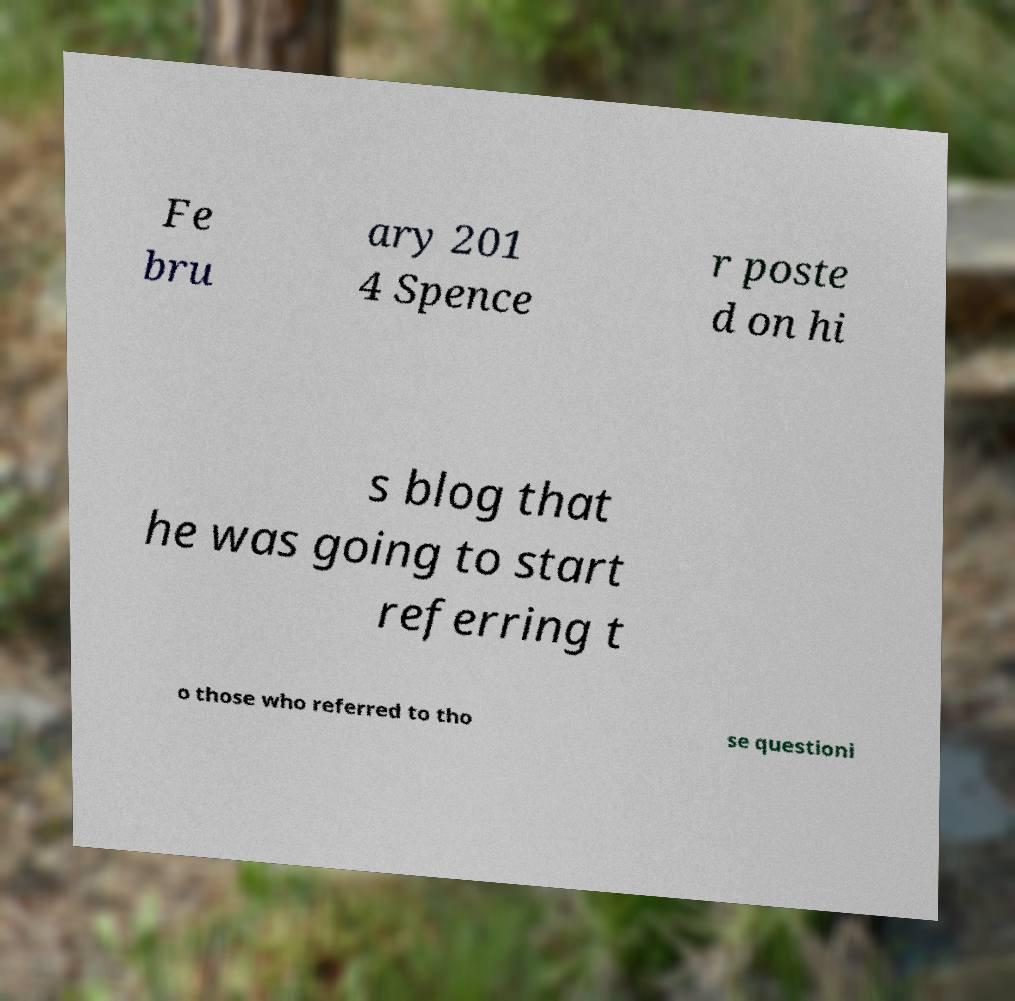I need the written content from this picture converted into text. Can you do that? Fe bru ary 201 4 Spence r poste d on hi s blog that he was going to start referring t o those who referred to tho se questioni 